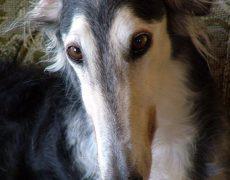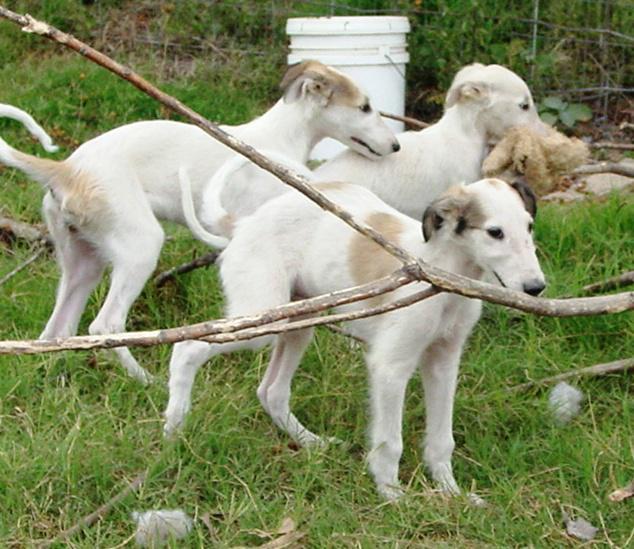The first image is the image on the left, the second image is the image on the right. For the images displayed, is the sentence "There are four dogs in total." factually correct? Answer yes or no. Yes. The first image is the image on the left, the second image is the image on the right. For the images shown, is this caption "An image shows at least three hounds sitting upright in a row on green grass." true? Answer yes or no. No. 